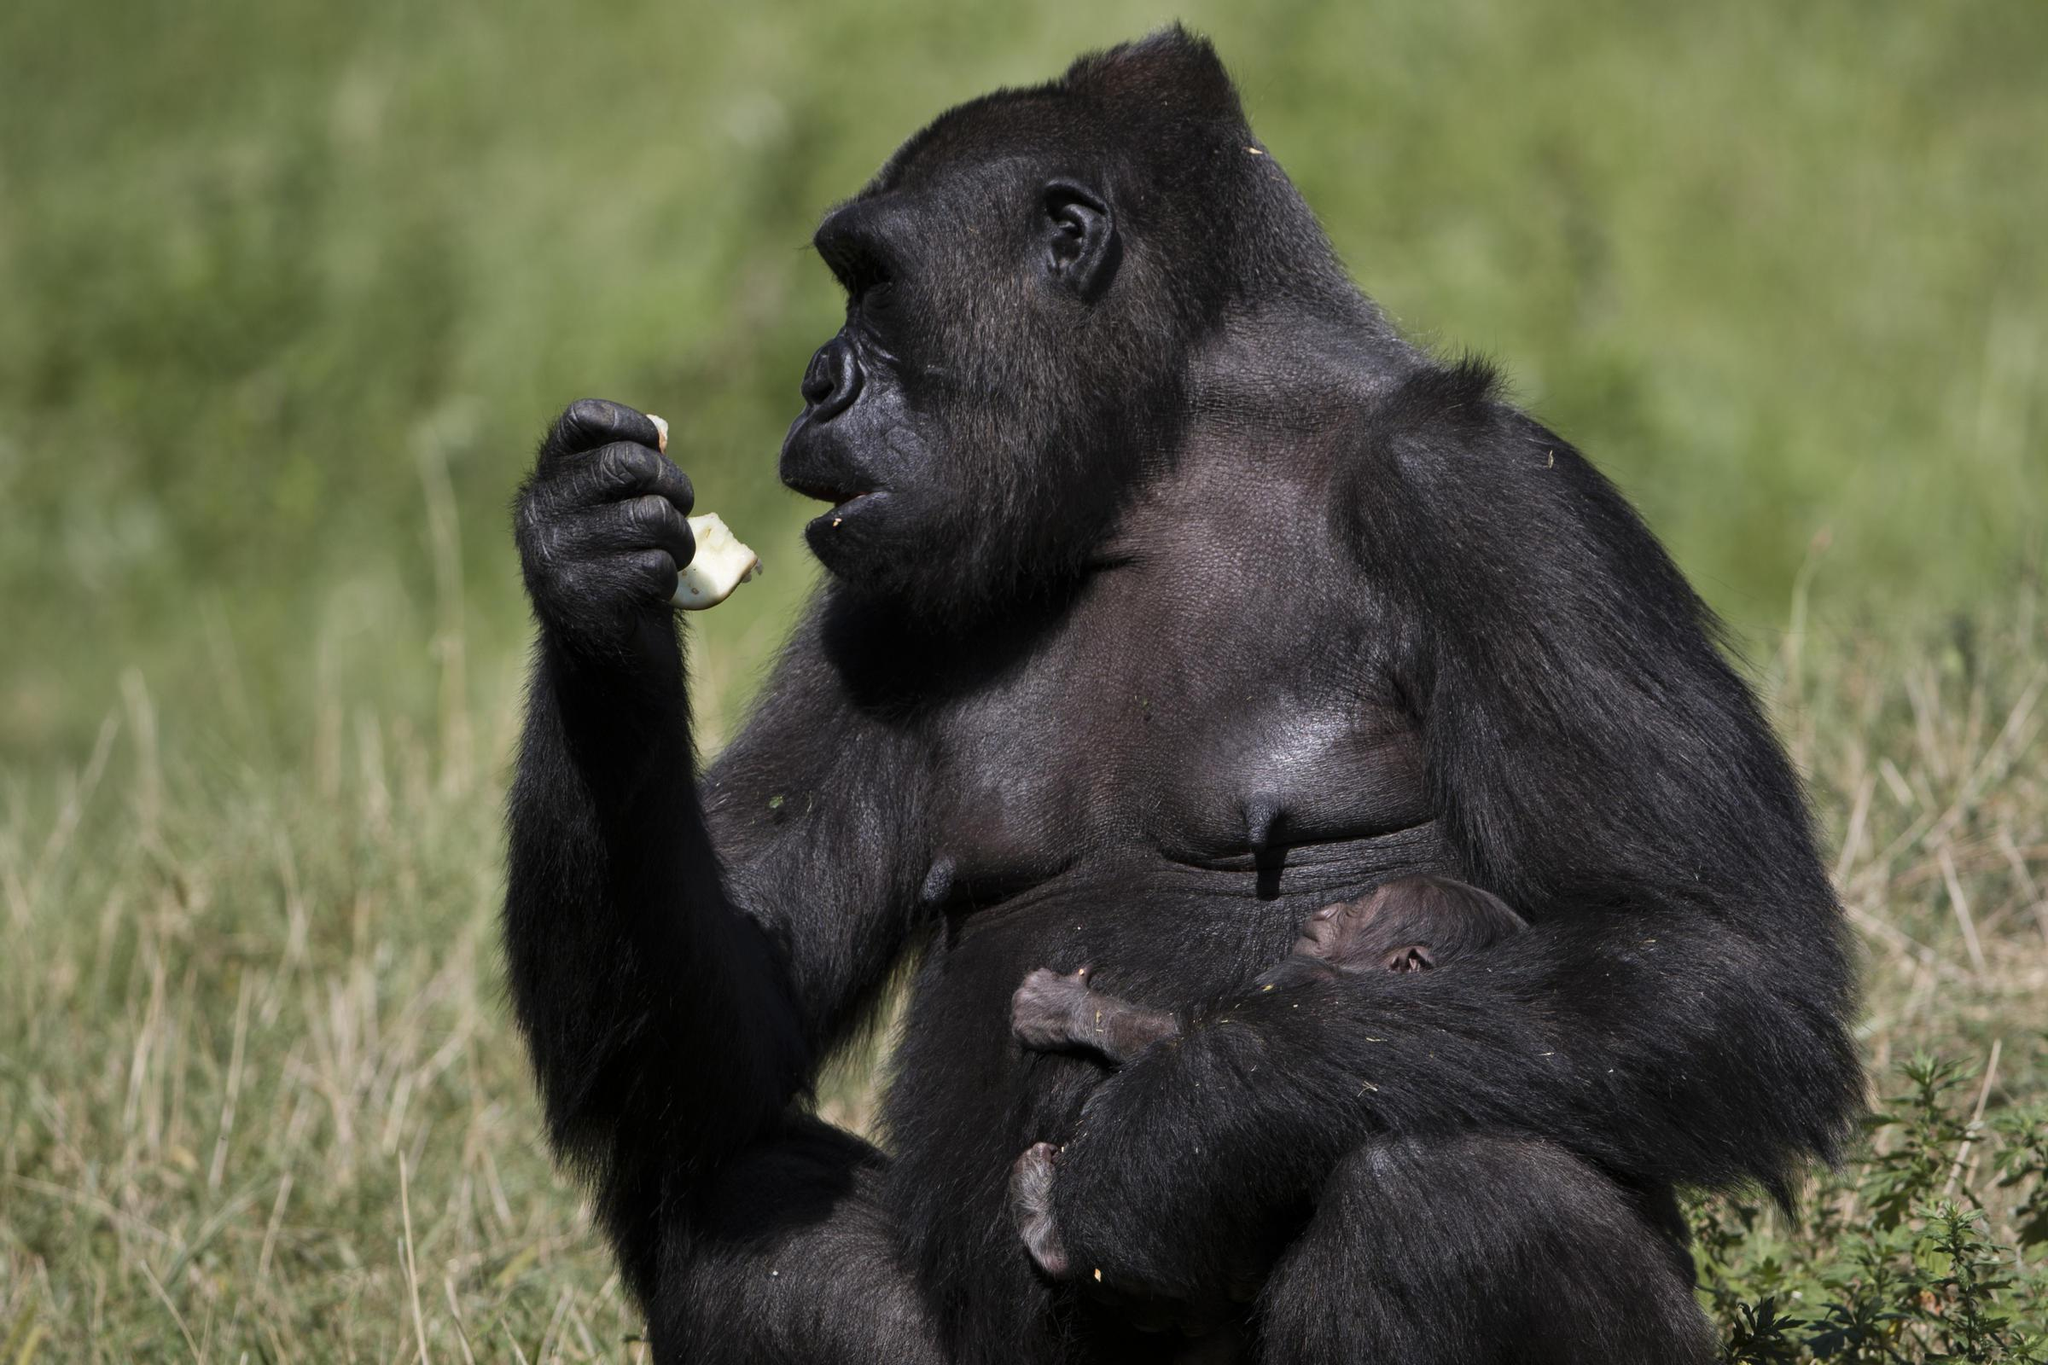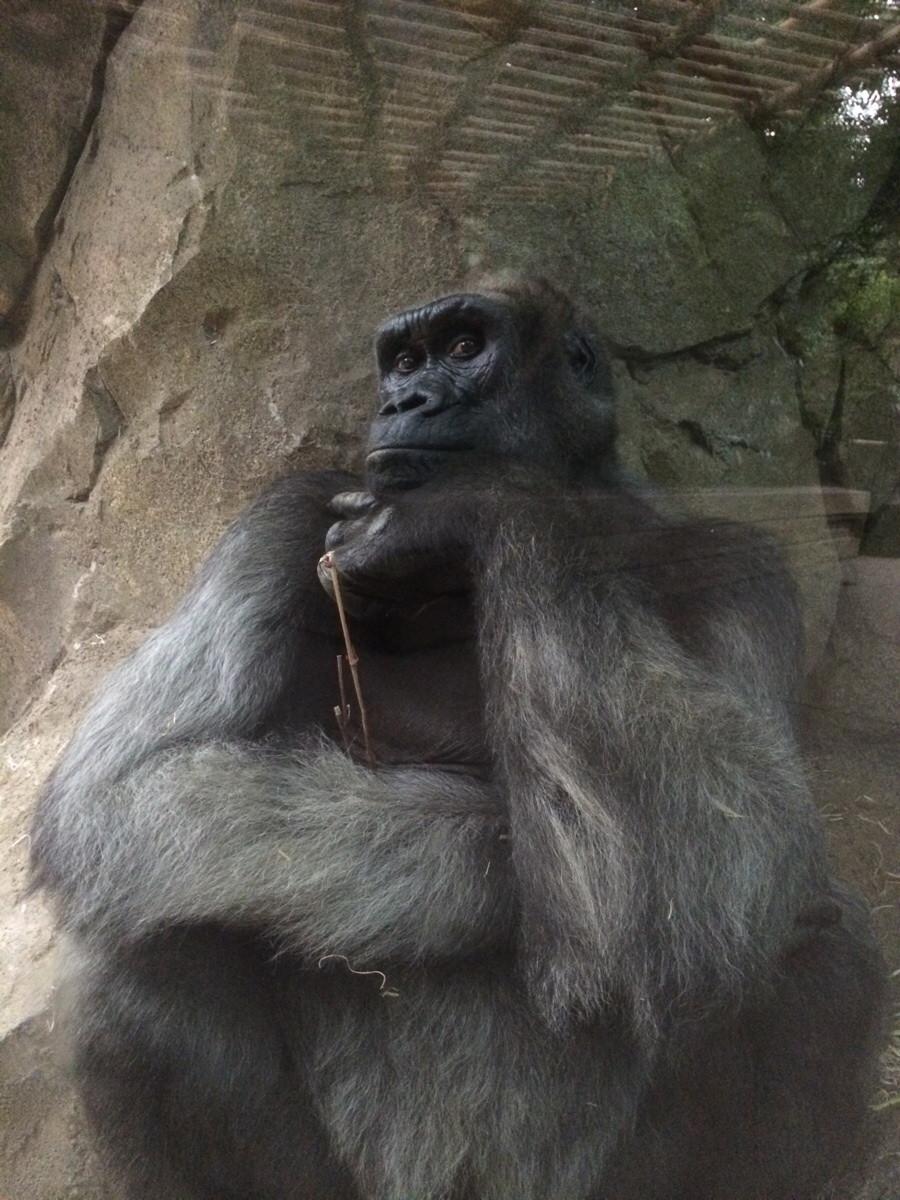The first image is the image on the left, the second image is the image on the right. For the images shown, is this caption "The left image shows a mother gorilla's bent arm around a baby gorilla held to her chest and her other arm held up to her face." true? Answer yes or no. Yes. The first image is the image on the left, the second image is the image on the right. Examine the images to the left and right. Is the description "A gorilla is holding a baby gorilla in its arms." accurate? Answer yes or no. No. 